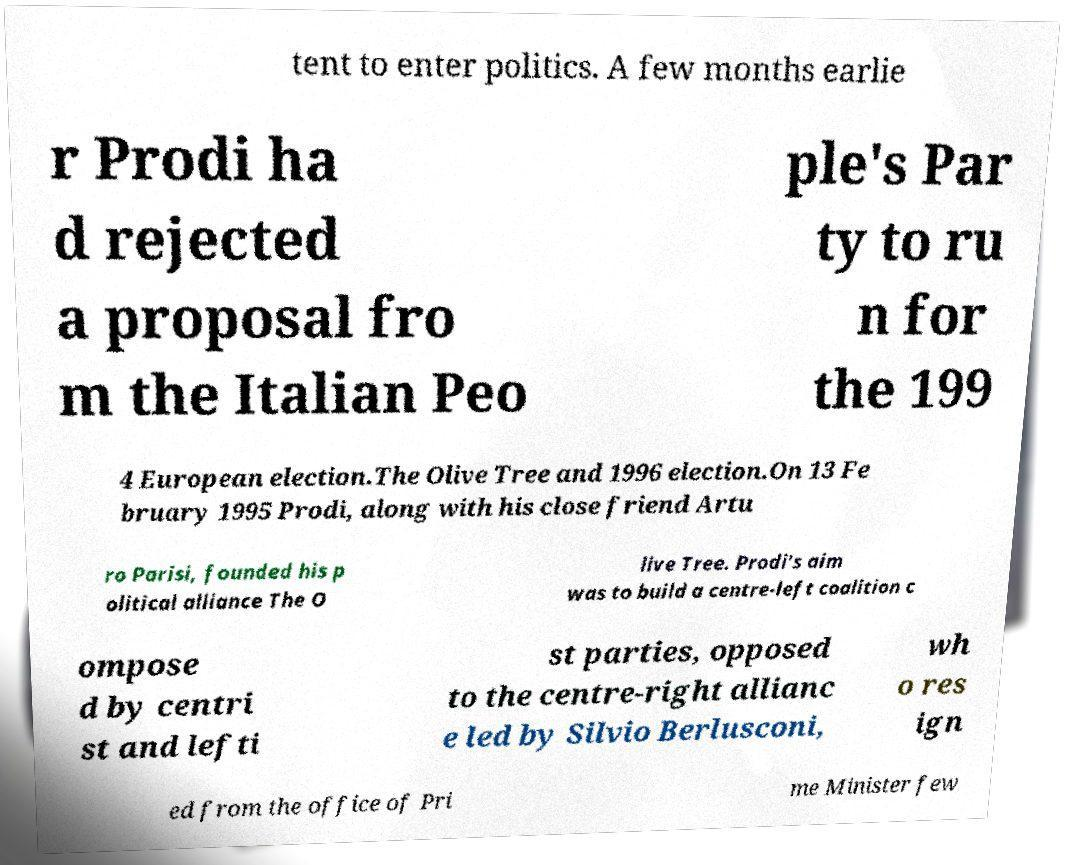There's text embedded in this image that I need extracted. Can you transcribe it verbatim? tent to enter politics. A few months earlie r Prodi ha d rejected a proposal fro m the Italian Peo ple's Par ty to ru n for the 199 4 European election.The Olive Tree and 1996 election.On 13 Fe bruary 1995 Prodi, along with his close friend Artu ro Parisi, founded his p olitical alliance The O live Tree. Prodi's aim was to build a centre-left coalition c ompose d by centri st and lefti st parties, opposed to the centre-right allianc e led by Silvio Berlusconi, wh o res ign ed from the office of Pri me Minister few 